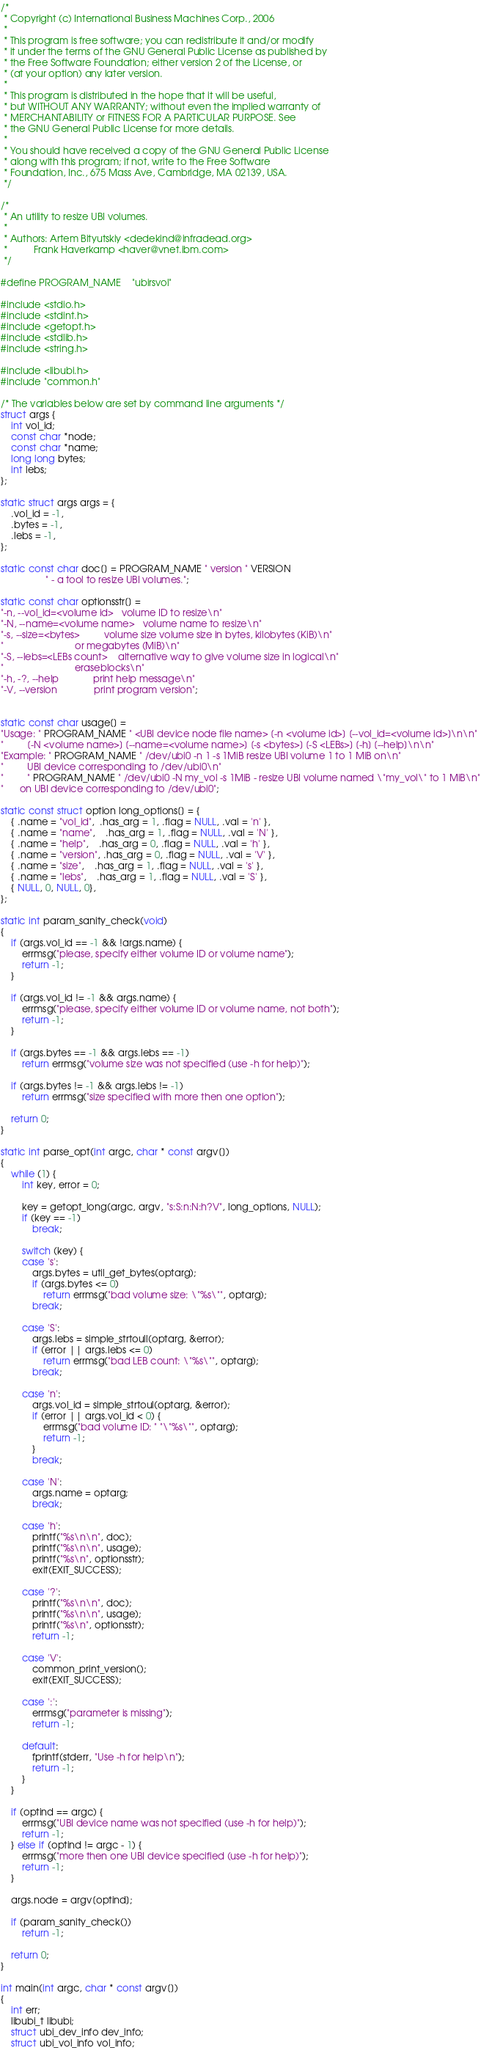<code> <loc_0><loc_0><loc_500><loc_500><_C_>/*
 * Copyright (c) International Business Machines Corp., 2006
 *
 * This program is free software; you can redistribute it and/or modify
 * it under the terms of the GNU General Public License as published by
 * the Free Software Foundation; either version 2 of the License, or
 * (at your option) any later version.
 *
 * This program is distributed in the hope that it will be useful,
 * but WITHOUT ANY WARRANTY; without even the implied warranty of
 * MERCHANTABILITY or FITNESS FOR A PARTICULAR PURPOSE. See
 * the GNU General Public License for more details.
 *
 * You should have received a copy of the GNU General Public License
 * along with this program; if not, write to the Free Software
 * Foundation, Inc., 675 Mass Ave, Cambridge, MA 02139, USA.
 */

/*
 * An utility to resize UBI volumes.
 *
 * Authors: Artem Bityutskiy <dedekind@infradead.org>
 *          Frank Haverkamp <haver@vnet.ibm.com>
 */

#define PROGRAM_NAME    "ubirsvol"

#include <stdio.h>
#include <stdint.h>
#include <getopt.h>
#include <stdlib.h>
#include <string.h>

#include <libubi.h>
#include "common.h"

/* The variables below are set by command line arguments */
struct args {
	int vol_id;
	const char *node;
	const char *name;
	long long bytes;
	int lebs;
};

static struct args args = {
	.vol_id = -1,
	.bytes = -1,
	.lebs = -1,
};

static const char doc[] = PROGRAM_NAME " version " VERSION
				 " - a tool to resize UBI volumes.";

static const char optionsstr[] =
"-n, --vol_id=<volume id>   volume ID to resize\n"
"-N, --name=<volume name>   volume name to resize\n"
"-s, --size=<bytes>         volume size volume size in bytes, kilobytes (KiB)\n"
"                           or megabytes (MiB)\n"
"-S, --lebs=<LEBs count>    alternative way to give volume size in logical\n"
"                           eraseblocks\n"
"-h, -?, --help             print help message\n"
"-V, --version              print program version";


static const char usage[] =
"Usage: " PROGRAM_NAME " <UBI device node file name> [-n <volume id>] [--vol_id=<volume id>]\n\n"
"         [-N <volume name>] [--name=<volume name>] [-s <bytes>] [-S <LEBs>] [-h] [--help]\n\n"
"Example: " PROGRAM_NAME " /dev/ubi0 -n 1 -s 1MiB resize UBI volume 1 to 1 MiB on\n"
"         UBI device corresponding to /dev/ubi0\n"
"         " PROGRAM_NAME " /dev/ubi0 -N my_vol -s 1MiB - resize UBI volume named \"my_vol\" to 1 MiB\n"
"	  on UBI device corresponding to /dev/ubi0";

static const struct option long_options[] = {
	{ .name = "vol_id",  .has_arg = 1, .flag = NULL, .val = 'n' },
	{ .name = "name",    .has_arg = 1, .flag = NULL, .val = 'N' },
	{ .name = "help",    .has_arg = 0, .flag = NULL, .val = 'h' },
	{ .name = "version", .has_arg = 0, .flag = NULL, .val = 'V' },
	{ .name = "size",    .has_arg = 1, .flag = NULL, .val = 's' },
	{ .name = "lebs",    .has_arg = 1, .flag = NULL, .val = 'S' },
	{ NULL, 0, NULL, 0},
};

static int param_sanity_check(void)
{
	if (args.vol_id == -1 && !args.name) {
		errmsg("please, specify either volume ID or volume name");
		return -1;
	}

	if (args.vol_id != -1 && args.name) {
		errmsg("please, specify either volume ID or volume name, not both");
		return -1;
	}

	if (args.bytes == -1 && args.lebs == -1)
		return errmsg("volume size was not specified (use -h for help)");

	if (args.bytes != -1 && args.lebs != -1)
		return errmsg("size specified with more then one option");

	return 0;
}

static int parse_opt(int argc, char * const argv[])
{
	while (1) {
		int key, error = 0;

		key = getopt_long(argc, argv, "s:S:n:N:h?V", long_options, NULL);
		if (key == -1)
			break;

		switch (key) {
		case 's':
			args.bytes = util_get_bytes(optarg);
			if (args.bytes <= 0)
				return errmsg("bad volume size: \"%s\"", optarg);
			break;

		case 'S':
			args.lebs = simple_strtoull(optarg, &error);
			if (error || args.lebs <= 0)
				return errmsg("bad LEB count: \"%s\"", optarg);
			break;

		case 'n':
			args.vol_id = simple_strtoul(optarg, &error);
			if (error || args.vol_id < 0) {
				errmsg("bad volume ID: " "\"%s\"", optarg);
				return -1;
			}
			break;

		case 'N':
			args.name = optarg;
			break;

		case 'h':
			printf("%s\n\n", doc);
			printf("%s\n\n", usage);
			printf("%s\n", optionsstr);
			exit(EXIT_SUCCESS);

		case '?':
			printf("%s\n\n", doc);
			printf("%s\n\n", usage);
			printf("%s\n", optionsstr);
			return -1;

		case 'V':
			common_print_version();
			exit(EXIT_SUCCESS);

		case ':':
			errmsg("parameter is missing");
			return -1;

		default:
			fprintf(stderr, "Use -h for help\n");
			return -1;
		}
	}

	if (optind == argc) {
		errmsg("UBI device name was not specified (use -h for help)");
		return -1;
	} else if (optind != argc - 1) {
		errmsg("more then one UBI device specified (use -h for help)");
		return -1;
	}

	args.node = argv[optind];

	if (param_sanity_check())
		return -1;

	return 0;
}

int main(int argc, char * const argv[])
{
	int err;
	libubi_t libubi;
	struct ubi_dev_info dev_info;
	struct ubi_vol_info vol_info;
</code> 